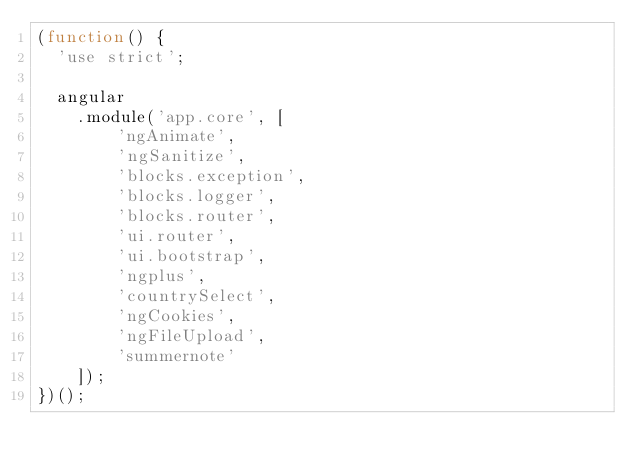Convert code to text. <code><loc_0><loc_0><loc_500><loc_500><_JavaScript_>(function() {
  'use strict';

  angular
    .module('app.core', [
        'ngAnimate',
        'ngSanitize',
        'blocks.exception',
        'blocks.logger',
        'blocks.router',
        'ui.router',
        'ui.bootstrap',
        'ngplus',
        'countrySelect',
        'ngCookies',
        'ngFileUpload',
        'summernote'
    ]);
})();
</code> 